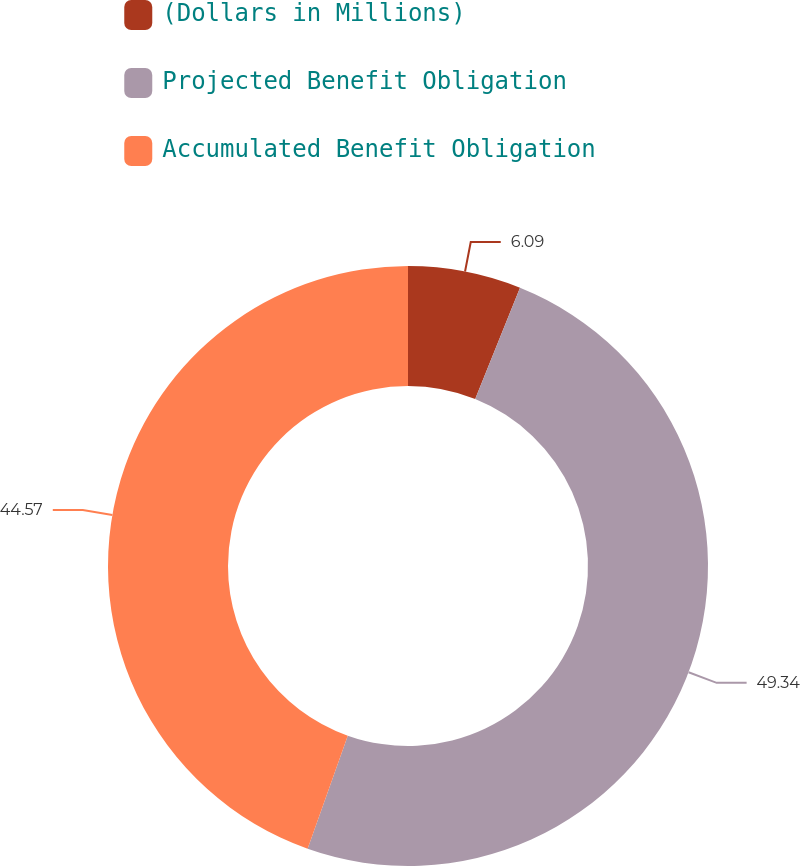Convert chart to OTSL. <chart><loc_0><loc_0><loc_500><loc_500><pie_chart><fcel>(Dollars in Millions)<fcel>Projected Benefit Obligation<fcel>Accumulated Benefit Obligation<nl><fcel>6.09%<fcel>49.34%<fcel>44.57%<nl></chart> 